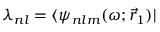Convert formula to latex. <formula><loc_0><loc_0><loc_500><loc_500>{ \lambda _ { n l } = \langle \psi _ { n l m } ( \omega ; \vec { r } _ { 1 } ) | }</formula> 